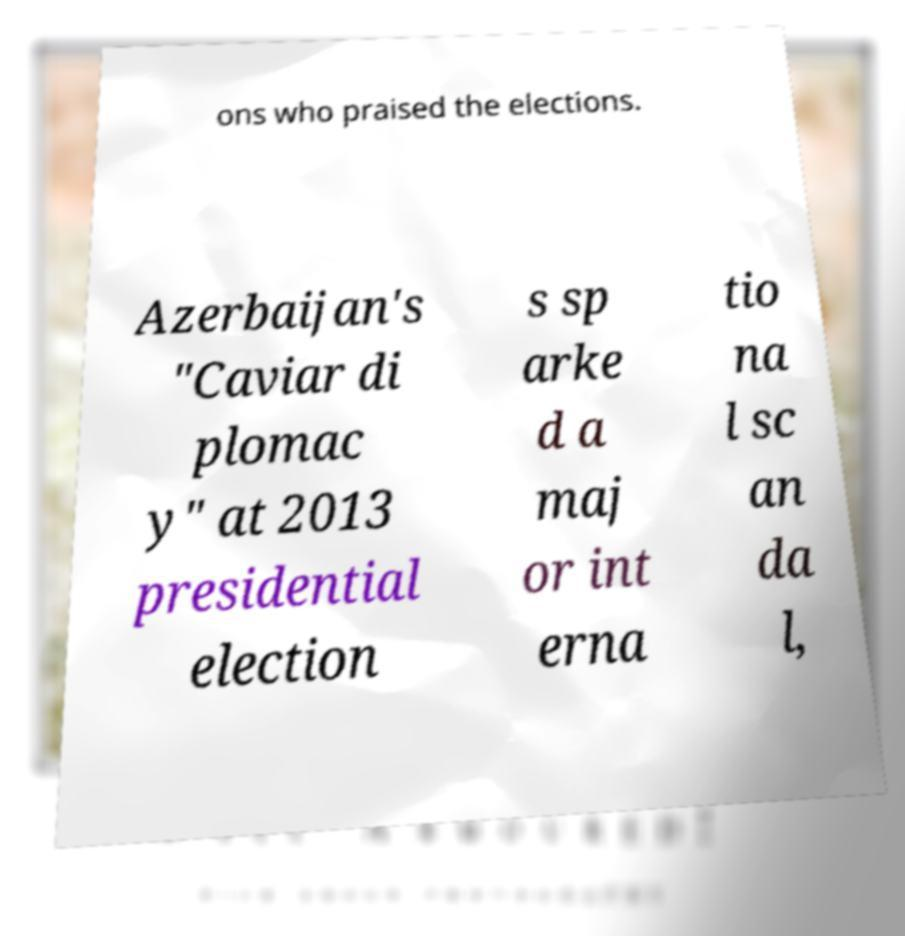Can you read and provide the text displayed in the image?This photo seems to have some interesting text. Can you extract and type it out for me? ons who praised the elections. Azerbaijan's "Caviar di plomac y" at 2013 presidential election s sp arke d a maj or int erna tio na l sc an da l, 